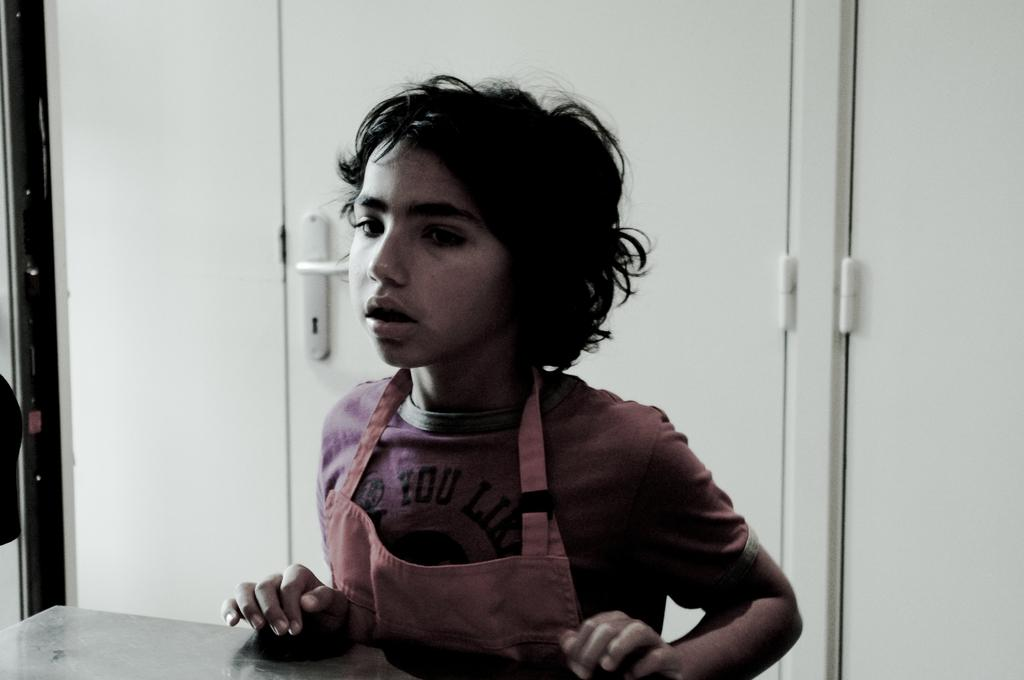Who is the main subject in the image? There is a boy in the center of the image. What can be seen in the background of the image? There is a white door in the background of the image. Where is the boy's mom at the seashore in the image? There is no mention of a mom or a seashore in the image; it only features a boy and a white door. 